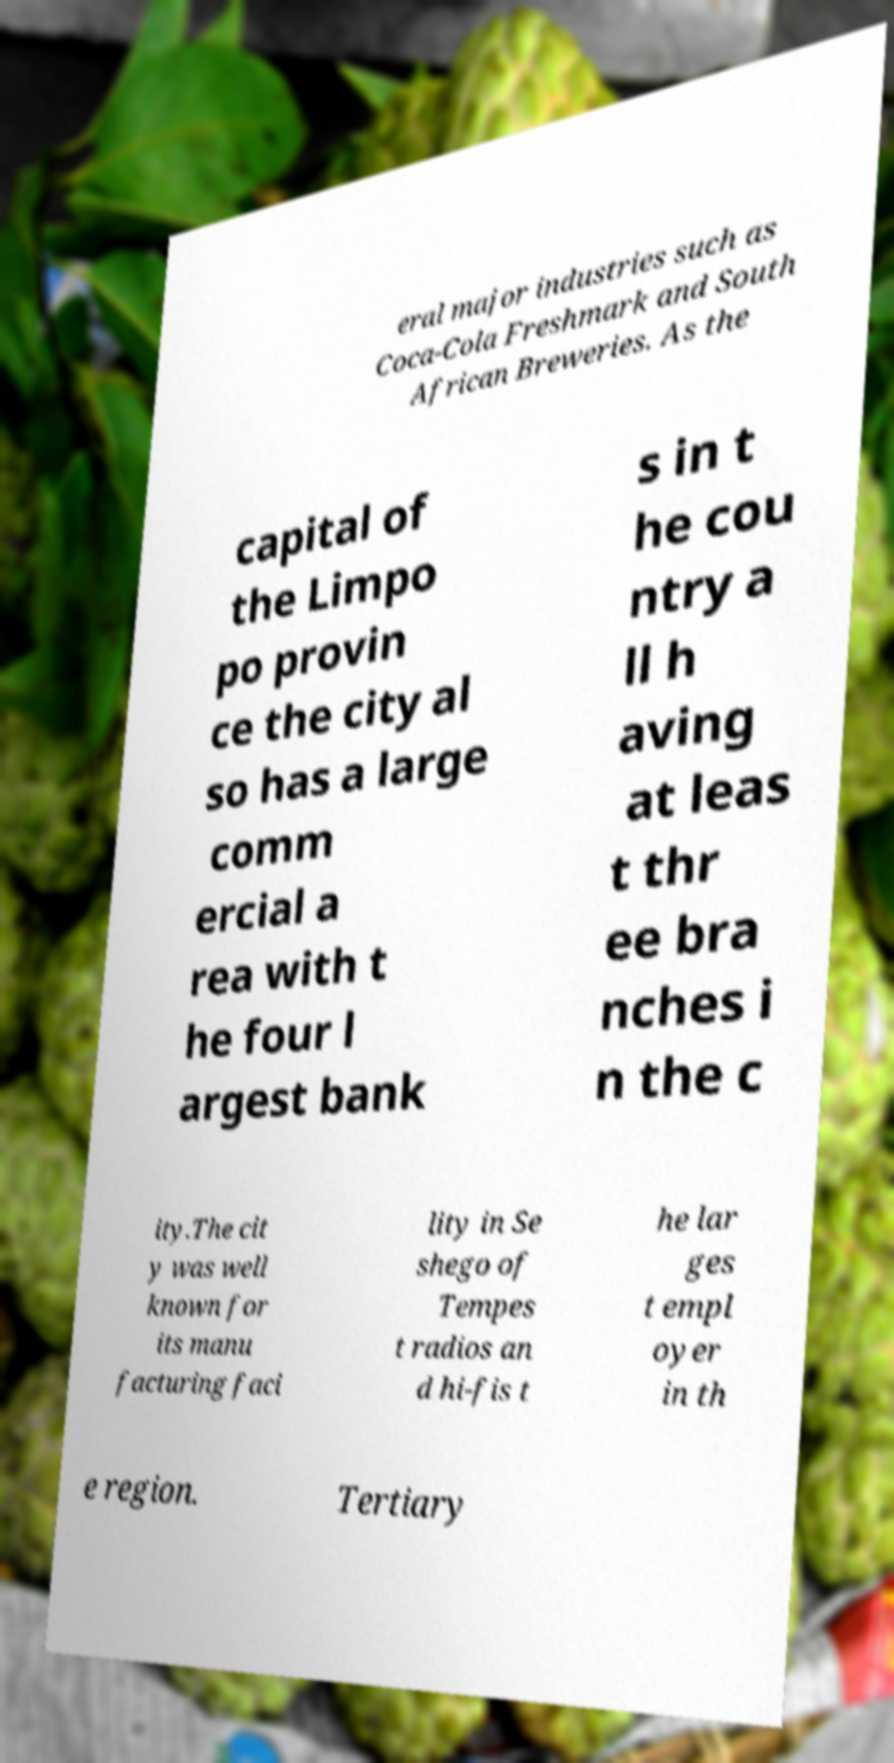Please read and relay the text visible in this image. What does it say? eral major industries such as Coca-Cola Freshmark and South African Breweries. As the capital of the Limpo po provin ce the city al so has a large comm ercial a rea with t he four l argest bank s in t he cou ntry a ll h aving at leas t thr ee bra nches i n the c ity.The cit y was well known for its manu facturing faci lity in Se shego of Tempes t radios an d hi-fis t he lar ges t empl oyer in th e region. Tertiary 